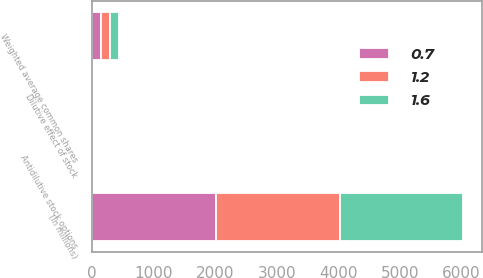Convert chart. <chart><loc_0><loc_0><loc_500><loc_500><stacked_bar_chart><ecel><fcel>(In millions)<fcel>Weighted average common shares<fcel>Dilutive effect of stock<fcel>Antidilutive stock options<nl><fcel>1.2<fcel>2012<fcel>142.7<fcel>2.6<fcel>1.6<nl><fcel>1.6<fcel>2011<fcel>145.8<fcel>2.6<fcel>0.7<nl><fcel>0.7<fcel>2010<fcel>144.4<fcel>2.4<fcel>1.2<nl></chart> 